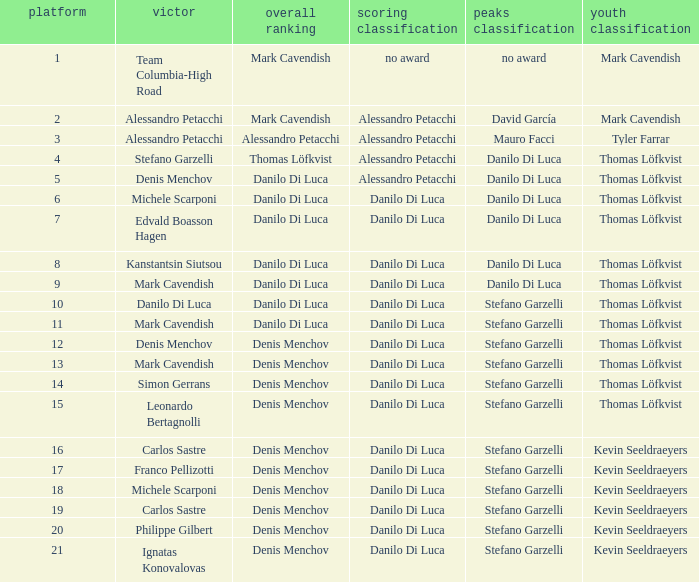In the general classification, who emerges as the winner when it includes thomas löfkvist? Stefano Garzelli. 